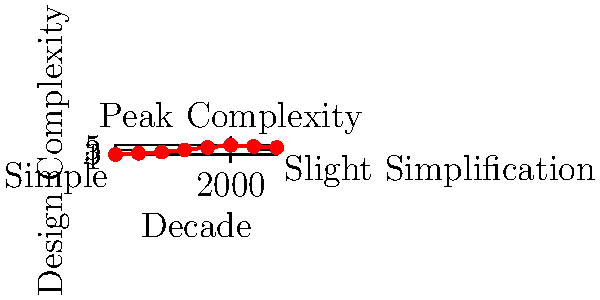Based on the graph showing the evolution of a cartoon character's design complexity over different decades, which period marked the peak of design intricacy, and what trend followed immediately after? To answer this question, let's analyze the graph step-by-step:

1. The x-axis represents decades from 1950 to 2020.
2. The y-axis represents design complexity, with higher values indicating more intricate designs.
3. We can observe that the line steadily increases from 1950 to 2000, indicating growing complexity.
4. The peak of the graph occurs at the year 2000, reaching the highest point on the y-axis.
5. After 2000, we see a slight downward trend, indicating a decrease in complexity.
6. This downward trend continues from 2000 to 2020, showing a slight simplification in design.

Therefore, the peak of design intricacy occurred in 2000, and the trend that followed immediately after was a slight simplification or reduction in complexity.
Answer: 2000; slight simplification 